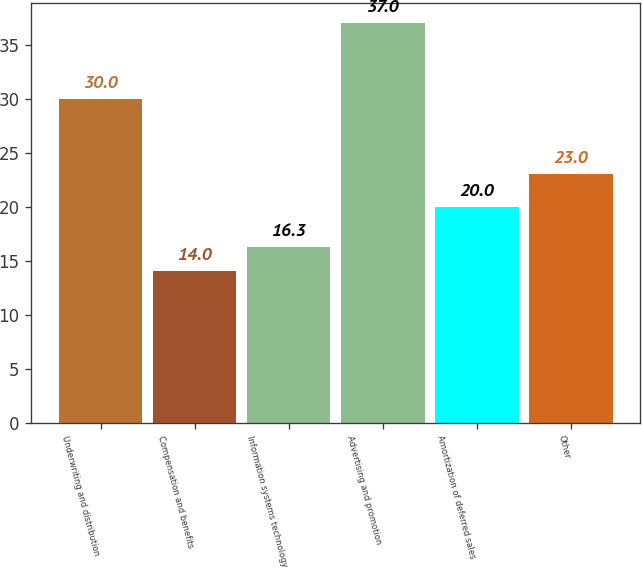Convert chart to OTSL. <chart><loc_0><loc_0><loc_500><loc_500><bar_chart><fcel>Underwriting and distribution<fcel>Compensation and benefits<fcel>Information systems technology<fcel>Advertising and promotion<fcel>Amortization of deferred sales<fcel>Other<nl><fcel>30<fcel>14<fcel>16.3<fcel>37<fcel>20<fcel>23<nl></chart> 